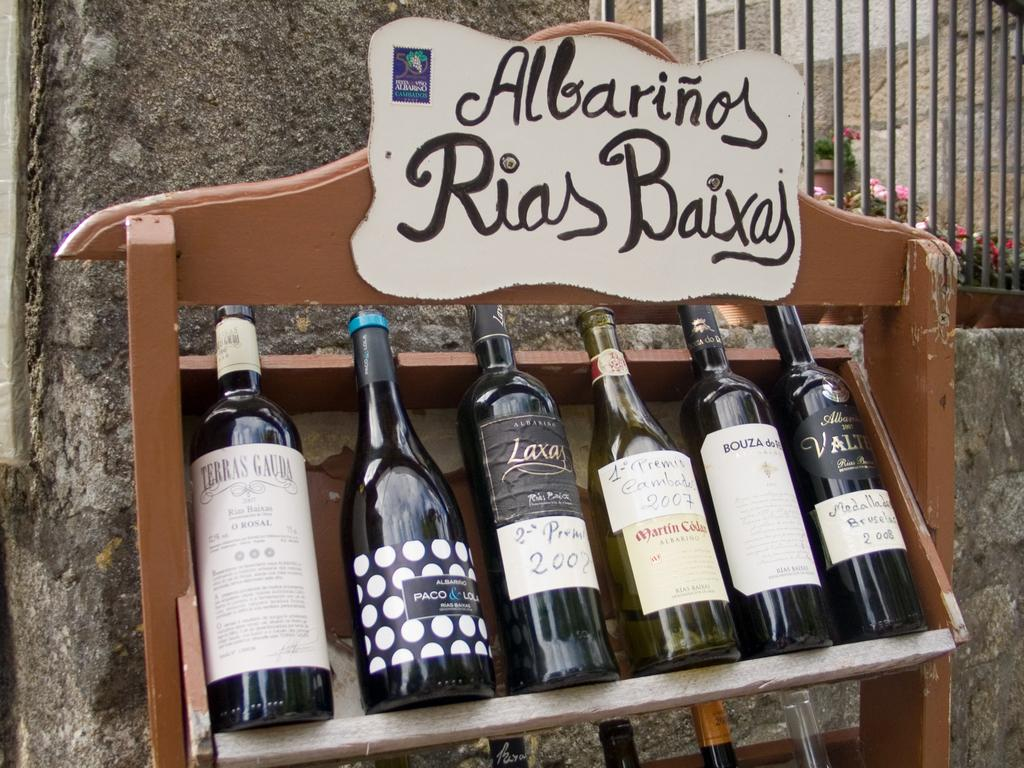<image>
Present a compact description of the photo's key features. Several bottles of wine sit outside on a rack under an Albarinos sign. 